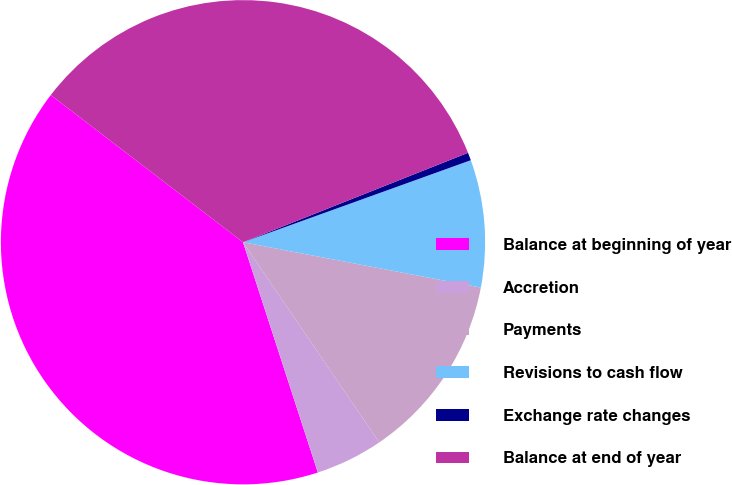Convert chart. <chart><loc_0><loc_0><loc_500><loc_500><pie_chart><fcel>Balance at beginning of year<fcel>Accretion<fcel>Payments<fcel>Revisions to cash flow<fcel>Exchange rate changes<fcel>Balance at end of year<nl><fcel>40.4%<fcel>4.51%<fcel>12.49%<fcel>8.5%<fcel>0.52%<fcel>33.58%<nl></chart> 